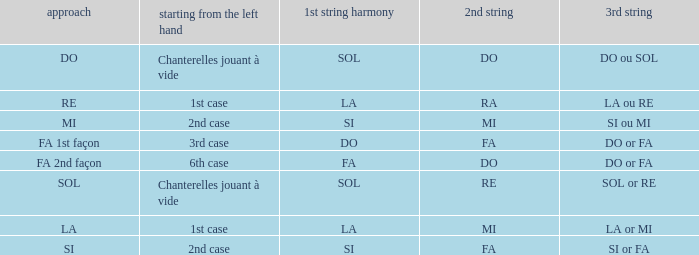For the 2nd string of Do and an Accord du 1st string of FA what is the Depart de la main gauche? 6th case. 